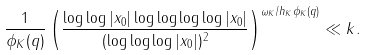<formula> <loc_0><loc_0><loc_500><loc_500>\frac { 1 } { \phi _ { K } ( q ) } \left ( \frac { \log \log | x _ { 0 } | \log \log \log \log | x _ { 0 } | } { ( \log \log \log | x _ { 0 } | ) ^ { 2 } } \right ) ^ { \omega _ { K } / h _ { K } \phi _ { K } ( q ) } \ll k .</formula> 